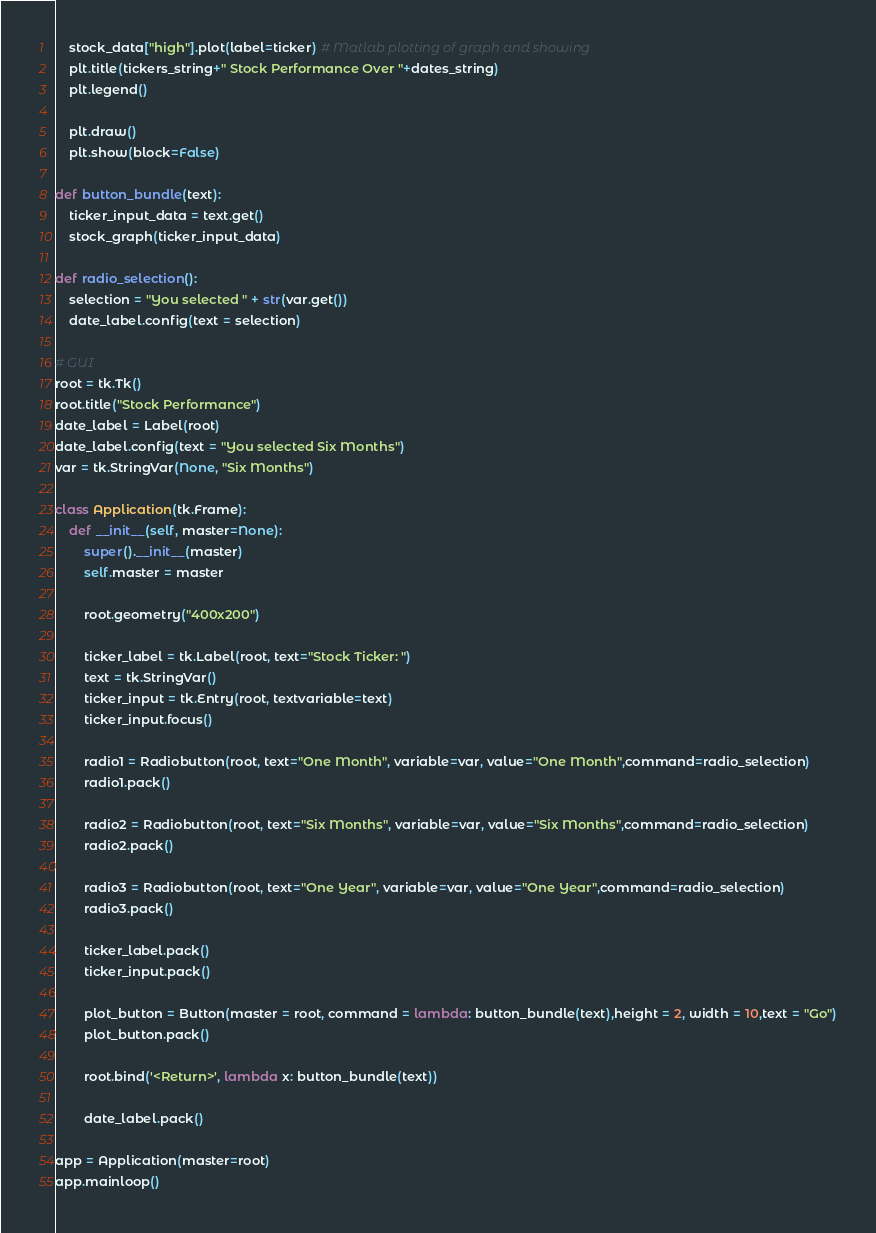Convert code to text. <code><loc_0><loc_0><loc_500><loc_500><_Python_>
    stock_data["high"].plot(label=ticker) # Matlab plotting of graph and showing
    plt.title(tickers_string+" Stock Performance Over "+dates_string)
    plt.legend()

    plt.draw()
    plt.show(block=False)
  
def button_bundle(text):
    ticker_input_data = text.get()
    stock_graph(ticker_input_data)

def radio_selection():
    selection = "You selected " + str(var.get())
    date_label.config(text = selection)

# GUI
root = tk.Tk()
root.title("Stock Performance")
date_label = Label(root)
date_label.config(text = "You selected Six Months")
var = tk.StringVar(None, "Six Months")

class Application(tk.Frame):
    def __init__(self, master=None):
        super().__init__(master)
        self.master = master
    
        root.geometry("400x200")

        ticker_label = tk.Label(root, text="Stock Ticker: ")
        text = tk.StringVar()
        ticker_input = tk.Entry(root, textvariable=text)
        ticker_input.focus()

        radio1 = Radiobutton(root, text="One Month", variable=var, value="One Month",command=radio_selection)
        radio1.pack()

        radio2 = Radiobutton(root, text="Six Months", variable=var, value="Six Months",command=radio_selection)
        radio2.pack()

        radio3 = Radiobutton(root, text="One Year", variable=var, value="One Year",command=radio_selection)
        radio3.pack()

        ticker_label.pack()
        ticker_input.pack()

        plot_button = Button(master = root, command = lambda: button_bundle(text),height = 2, width = 10,text = "Go")
        plot_button.pack()

        root.bind('<Return>', lambda x: button_bundle(text))

        date_label.pack()

app = Application(master=root)
app.mainloop()</code> 